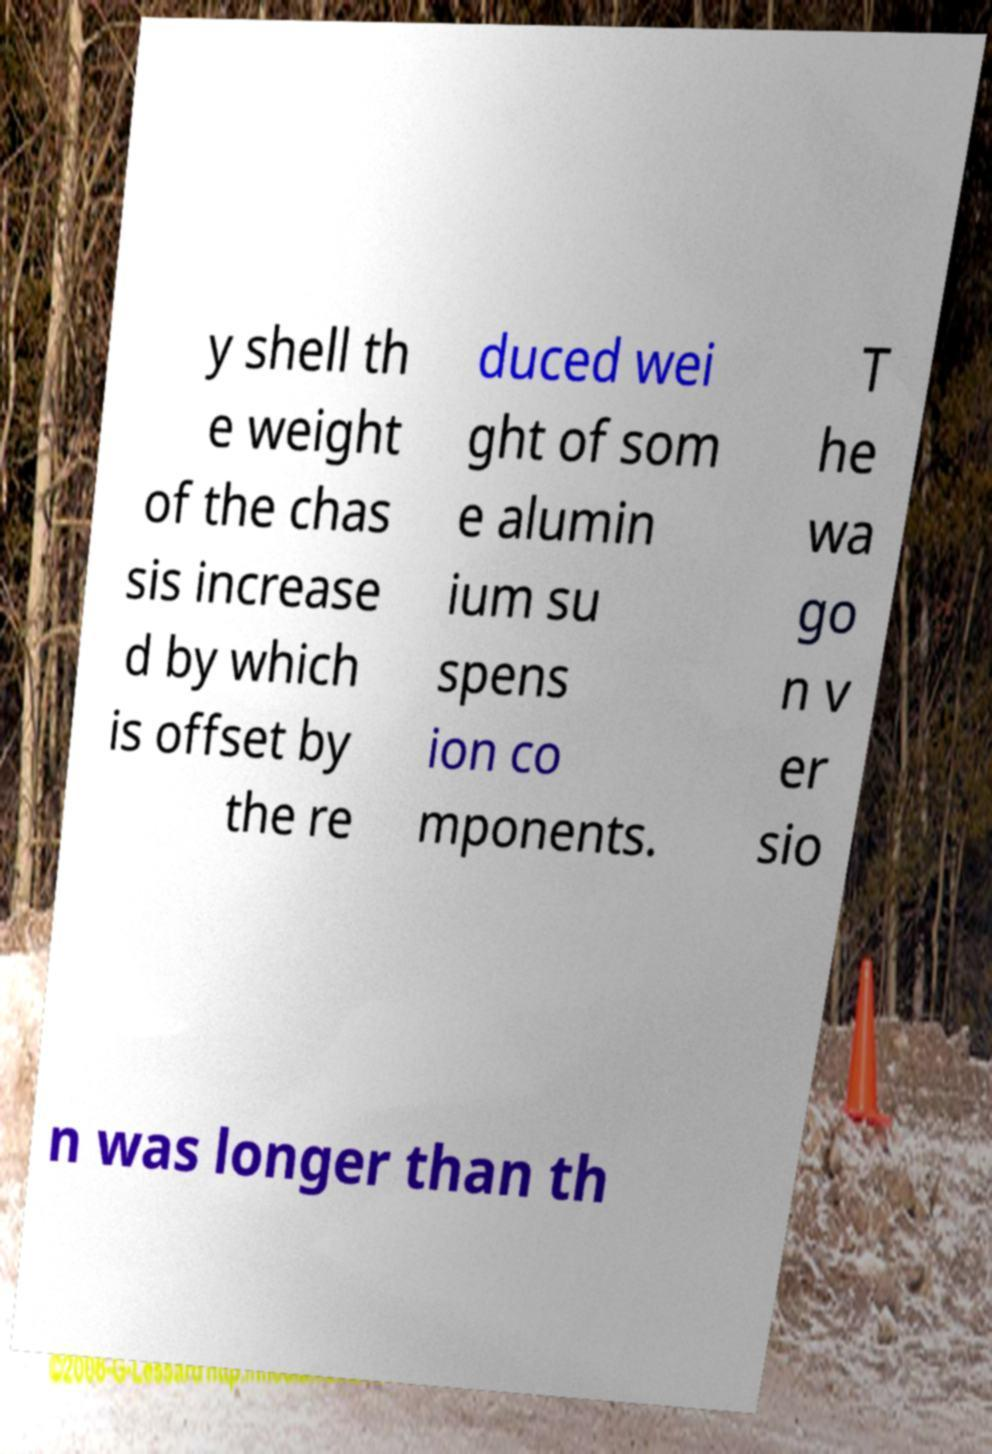Please identify and transcribe the text found in this image. y shell th e weight of the chas sis increase d by which is offset by the re duced wei ght of som e alumin ium su spens ion co mponents. T he wa go n v er sio n was longer than th 